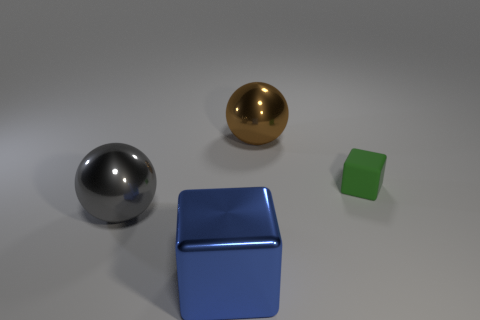What number of blue shiny blocks have the same size as the brown sphere?
Your answer should be compact. 1. Are there any small things of the same color as the big metal cube?
Provide a short and direct response. No. Do the green thing and the large block have the same material?
Offer a very short reply. No. What number of other large things are the same shape as the big gray object?
Make the answer very short. 1. The gray thing that is the same material as the large brown ball is what shape?
Your response must be concise. Sphere. There is a big ball behind the ball that is on the left side of the brown ball; what color is it?
Your answer should be very brief. Brown. Is the color of the large cube the same as the rubber thing?
Make the answer very short. No. There is a thing on the right side of the object that is behind the green object; what is it made of?
Your response must be concise. Rubber. There is another blue object that is the same shape as the small matte thing; what material is it?
Your answer should be very brief. Metal. There is a large brown metallic ball that is behind the ball that is in front of the rubber block; are there any brown metal objects that are right of it?
Offer a terse response. No. 